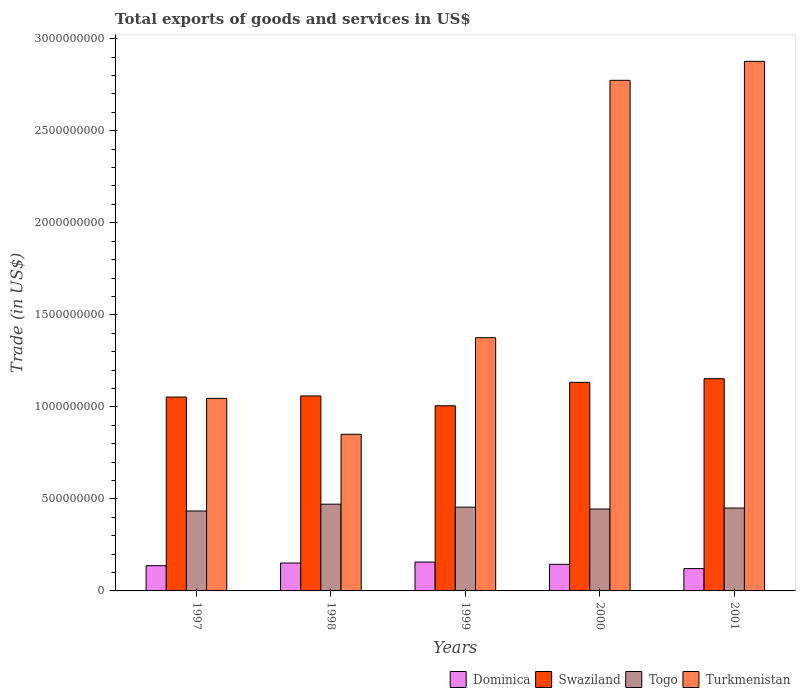How many different coloured bars are there?
Provide a succinct answer. 4. How many groups of bars are there?
Your response must be concise. 5. Are the number of bars per tick equal to the number of legend labels?
Provide a short and direct response. Yes. How many bars are there on the 3rd tick from the left?
Your response must be concise. 4. In how many cases, is the number of bars for a given year not equal to the number of legend labels?
Offer a terse response. 0. What is the total exports of goods and services in Dominica in 1998?
Make the answer very short. 1.52e+08. Across all years, what is the maximum total exports of goods and services in Turkmenistan?
Your response must be concise. 2.88e+09. Across all years, what is the minimum total exports of goods and services in Turkmenistan?
Your answer should be very brief. 8.51e+08. In which year was the total exports of goods and services in Turkmenistan minimum?
Ensure brevity in your answer.  1998. What is the total total exports of goods and services in Swaziland in the graph?
Your answer should be very brief. 5.40e+09. What is the difference between the total exports of goods and services in Togo in 1997 and that in 1999?
Make the answer very short. -2.08e+07. What is the difference between the total exports of goods and services in Togo in 1997 and the total exports of goods and services in Swaziland in 2001?
Your response must be concise. -7.19e+08. What is the average total exports of goods and services in Togo per year?
Make the answer very short. 4.51e+08. In the year 2000, what is the difference between the total exports of goods and services in Swaziland and total exports of goods and services in Togo?
Give a very brief answer. 6.88e+08. What is the ratio of the total exports of goods and services in Dominica in 1997 to that in 1998?
Ensure brevity in your answer.  0.9. Is the total exports of goods and services in Togo in 1997 less than that in 1998?
Make the answer very short. Yes. What is the difference between the highest and the second highest total exports of goods and services in Turkmenistan?
Your answer should be very brief. 1.03e+08. What is the difference between the highest and the lowest total exports of goods and services in Togo?
Make the answer very short. 3.69e+07. Is the sum of the total exports of goods and services in Swaziland in 1997 and 1999 greater than the maximum total exports of goods and services in Dominica across all years?
Offer a terse response. Yes. Is it the case that in every year, the sum of the total exports of goods and services in Togo and total exports of goods and services in Swaziland is greater than the sum of total exports of goods and services in Dominica and total exports of goods and services in Turkmenistan?
Keep it short and to the point. Yes. What does the 3rd bar from the left in 1999 represents?
Provide a short and direct response. Togo. What does the 4th bar from the right in 1997 represents?
Your answer should be very brief. Dominica. What is the difference between two consecutive major ticks on the Y-axis?
Keep it short and to the point. 5.00e+08. Are the values on the major ticks of Y-axis written in scientific E-notation?
Offer a terse response. No. Does the graph contain any zero values?
Make the answer very short. No. How many legend labels are there?
Ensure brevity in your answer.  4. What is the title of the graph?
Your response must be concise. Total exports of goods and services in US$. What is the label or title of the X-axis?
Your response must be concise. Years. What is the label or title of the Y-axis?
Your answer should be compact. Trade (in US$). What is the Trade (in US$) of Dominica in 1997?
Make the answer very short. 1.37e+08. What is the Trade (in US$) in Swaziland in 1997?
Ensure brevity in your answer.  1.05e+09. What is the Trade (in US$) in Togo in 1997?
Ensure brevity in your answer.  4.34e+08. What is the Trade (in US$) of Turkmenistan in 1997?
Your answer should be compact. 1.05e+09. What is the Trade (in US$) in Dominica in 1998?
Offer a very short reply. 1.52e+08. What is the Trade (in US$) in Swaziland in 1998?
Give a very brief answer. 1.06e+09. What is the Trade (in US$) of Togo in 1998?
Provide a succinct answer. 4.71e+08. What is the Trade (in US$) of Turkmenistan in 1998?
Your response must be concise. 8.51e+08. What is the Trade (in US$) in Dominica in 1999?
Provide a short and direct response. 1.57e+08. What is the Trade (in US$) of Swaziland in 1999?
Make the answer very short. 1.01e+09. What is the Trade (in US$) in Togo in 1999?
Provide a succinct answer. 4.55e+08. What is the Trade (in US$) in Turkmenistan in 1999?
Your answer should be very brief. 1.38e+09. What is the Trade (in US$) of Dominica in 2000?
Your answer should be compact. 1.45e+08. What is the Trade (in US$) of Swaziland in 2000?
Make the answer very short. 1.13e+09. What is the Trade (in US$) of Togo in 2000?
Provide a succinct answer. 4.45e+08. What is the Trade (in US$) of Turkmenistan in 2000?
Give a very brief answer. 2.77e+09. What is the Trade (in US$) of Dominica in 2001?
Your answer should be compact. 1.21e+08. What is the Trade (in US$) in Swaziland in 2001?
Provide a short and direct response. 1.15e+09. What is the Trade (in US$) of Togo in 2001?
Your answer should be very brief. 4.50e+08. What is the Trade (in US$) of Turkmenistan in 2001?
Provide a short and direct response. 2.88e+09. Across all years, what is the maximum Trade (in US$) in Dominica?
Give a very brief answer. 1.57e+08. Across all years, what is the maximum Trade (in US$) of Swaziland?
Ensure brevity in your answer.  1.15e+09. Across all years, what is the maximum Trade (in US$) of Togo?
Provide a short and direct response. 4.71e+08. Across all years, what is the maximum Trade (in US$) of Turkmenistan?
Make the answer very short. 2.88e+09. Across all years, what is the minimum Trade (in US$) of Dominica?
Offer a terse response. 1.21e+08. Across all years, what is the minimum Trade (in US$) in Swaziland?
Give a very brief answer. 1.01e+09. Across all years, what is the minimum Trade (in US$) in Togo?
Provide a short and direct response. 4.34e+08. Across all years, what is the minimum Trade (in US$) in Turkmenistan?
Your answer should be compact. 8.51e+08. What is the total Trade (in US$) of Dominica in the graph?
Offer a very short reply. 7.11e+08. What is the total Trade (in US$) of Swaziland in the graph?
Offer a terse response. 5.40e+09. What is the total Trade (in US$) in Togo in the graph?
Your answer should be compact. 2.26e+09. What is the total Trade (in US$) in Turkmenistan in the graph?
Give a very brief answer. 8.92e+09. What is the difference between the Trade (in US$) of Dominica in 1997 and that in 1998?
Offer a terse response. -1.45e+07. What is the difference between the Trade (in US$) in Swaziland in 1997 and that in 1998?
Your response must be concise. -6.06e+06. What is the difference between the Trade (in US$) in Togo in 1997 and that in 1998?
Keep it short and to the point. -3.69e+07. What is the difference between the Trade (in US$) of Turkmenistan in 1997 and that in 1998?
Give a very brief answer. 1.95e+08. What is the difference between the Trade (in US$) of Dominica in 1997 and that in 1999?
Give a very brief answer. -1.97e+07. What is the difference between the Trade (in US$) of Swaziland in 1997 and that in 1999?
Offer a terse response. 4.71e+07. What is the difference between the Trade (in US$) of Togo in 1997 and that in 1999?
Your response must be concise. -2.08e+07. What is the difference between the Trade (in US$) in Turkmenistan in 1997 and that in 1999?
Your response must be concise. -3.30e+08. What is the difference between the Trade (in US$) of Dominica in 1997 and that in 2000?
Make the answer very short. -7.36e+06. What is the difference between the Trade (in US$) of Swaziland in 1997 and that in 2000?
Keep it short and to the point. -7.99e+07. What is the difference between the Trade (in US$) of Togo in 1997 and that in 2000?
Ensure brevity in your answer.  -1.07e+07. What is the difference between the Trade (in US$) in Turkmenistan in 1997 and that in 2000?
Your response must be concise. -1.73e+09. What is the difference between the Trade (in US$) of Dominica in 1997 and that in 2001?
Your answer should be compact. 1.59e+07. What is the difference between the Trade (in US$) of Swaziland in 1997 and that in 2001?
Your answer should be compact. -9.97e+07. What is the difference between the Trade (in US$) in Togo in 1997 and that in 2001?
Your answer should be compact. -1.60e+07. What is the difference between the Trade (in US$) in Turkmenistan in 1997 and that in 2001?
Make the answer very short. -1.83e+09. What is the difference between the Trade (in US$) of Dominica in 1998 and that in 1999?
Give a very brief answer. -5.21e+06. What is the difference between the Trade (in US$) of Swaziland in 1998 and that in 1999?
Your answer should be very brief. 5.31e+07. What is the difference between the Trade (in US$) in Togo in 1998 and that in 1999?
Your answer should be compact. 1.61e+07. What is the difference between the Trade (in US$) of Turkmenistan in 1998 and that in 1999?
Provide a succinct answer. -5.25e+08. What is the difference between the Trade (in US$) of Dominica in 1998 and that in 2000?
Keep it short and to the point. 7.09e+06. What is the difference between the Trade (in US$) in Swaziland in 1998 and that in 2000?
Your response must be concise. -7.38e+07. What is the difference between the Trade (in US$) of Togo in 1998 and that in 2000?
Offer a very short reply. 2.62e+07. What is the difference between the Trade (in US$) of Turkmenistan in 1998 and that in 2000?
Your answer should be very brief. -1.92e+09. What is the difference between the Trade (in US$) of Dominica in 1998 and that in 2001?
Ensure brevity in your answer.  3.04e+07. What is the difference between the Trade (in US$) of Swaziland in 1998 and that in 2001?
Ensure brevity in your answer.  -9.36e+07. What is the difference between the Trade (in US$) in Togo in 1998 and that in 2001?
Give a very brief answer. 2.09e+07. What is the difference between the Trade (in US$) of Turkmenistan in 1998 and that in 2001?
Your answer should be very brief. -2.03e+09. What is the difference between the Trade (in US$) in Dominica in 1999 and that in 2000?
Offer a terse response. 1.23e+07. What is the difference between the Trade (in US$) in Swaziland in 1999 and that in 2000?
Provide a short and direct response. -1.27e+08. What is the difference between the Trade (in US$) in Togo in 1999 and that in 2000?
Offer a very short reply. 1.01e+07. What is the difference between the Trade (in US$) in Turkmenistan in 1999 and that in 2000?
Keep it short and to the point. -1.40e+09. What is the difference between the Trade (in US$) of Dominica in 1999 and that in 2001?
Your answer should be compact. 3.56e+07. What is the difference between the Trade (in US$) of Swaziland in 1999 and that in 2001?
Offer a terse response. -1.47e+08. What is the difference between the Trade (in US$) of Togo in 1999 and that in 2001?
Ensure brevity in your answer.  4.75e+06. What is the difference between the Trade (in US$) of Turkmenistan in 1999 and that in 2001?
Make the answer very short. -1.50e+09. What is the difference between the Trade (in US$) of Dominica in 2000 and that in 2001?
Your answer should be compact. 2.33e+07. What is the difference between the Trade (in US$) of Swaziland in 2000 and that in 2001?
Your answer should be compact. -1.98e+07. What is the difference between the Trade (in US$) in Togo in 2000 and that in 2001?
Keep it short and to the point. -5.34e+06. What is the difference between the Trade (in US$) in Turkmenistan in 2000 and that in 2001?
Your answer should be compact. -1.03e+08. What is the difference between the Trade (in US$) in Dominica in 1997 and the Trade (in US$) in Swaziland in 1998?
Ensure brevity in your answer.  -9.22e+08. What is the difference between the Trade (in US$) of Dominica in 1997 and the Trade (in US$) of Togo in 1998?
Make the answer very short. -3.34e+08. What is the difference between the Trade (in US$) of Dominica in 1997 and the Trade (in US$) of Turkmenistan in 1998?
Make the answer very short. -7.14e+08. What is the difference between the Trade (in US$) of Swaziland in 1997 and the Trade (in US$) of Togo in 1998?
Provide a succinct answer. 5.82e+08. What is the difference between the Trade (in US$) in Swaziland in 1997 and the Trade (in US$) in Turkmenistan in 1998?
Make the answer very short. 2.02e+08. What is the difference between the Trade (in US$) in Togo in 1997 and the Trade (in US$) in Turkmenistan in 1998?
Keep it short and to the point. -4.17e+08. What is the difference between the Trade (in US$) in Dominica in 1997 and the Trade (in US$) in Swaziland in 1999?
Your response must be concise. -8.69e+08. What is the difference between the Trade (in US$) in Dominica in 1997 and the Trade (in US$) in Togo in 1999?
Offer a terse response. -3.18e+08. What is the difference between the Trade (in US$) of Dominica in 1997 and the Trade (in US$) of Turkmenistan in 1999?
Provide a short and direct response. -1.24e+09. What is the difference between the Trade (in US$) of Swaziland in 1997 and the Trade (in US$) of Togo in 1999?
Ensure brevity in your answer.  5.98e+08. What is the difference between the Trade (in US$) in Swaziland in 1997 and the Trade (in US$) in Turkmenistan in 1999?
Offer a very short reply. -3.23e+08. What is the difference between the Trade (in US$) in Togo in 1997 and the Trade (in US$) in Turkmenistan in 1999?
Your response must be concise. -9.41e+08. What is the difference between the Trade (in US$) in Dominica in 1997 and the Trade (in US$) in Swaziland in 2000?
Ensure brevity in your answer.  -9.96e+08. What is the difference between the Trade (in US$) in Dominica in 1997 and the Trade (in US$) in Togo in 2000?
Give a very brief answer. -3.08e+08. What is the difference between the Trade (in US$) of Dominica in 1997 and the Trade (in US$) of Turkmenistan in 2000?
Provide a succinct answer. -2.64e+09. What is the difference between the Trade (in US$) in Swaziland in 1997 and the Trade (in US$) in Togo in 2000?
Ensure brevity in your answer.  6.08e+08. What is the difference between the Trade (in US$) of Swaziland in 1997 and the Trade (in US$) of Turkmenistan in 2000?
Provide a short and direct response. -1.72e+09. What is the difference between the Trade (in US$) of Togo in 1997 and the Trade (in US$) of Turkmenistan in 2000?
Give a very brief answer. -2.34e+09. What is the difference between the Trade (in US$) in Dominica in 1997 and the Trade (in US$) in Swaziland in 2001?
Keep it short and to the point. -1.02e+09. What is the difference between the Trade (in US$) of Dominica in 1997 and the Trade (in US$) of Togo in 2001?
Your answer should be very brief. -3.13e+08. What is the difference between the Trade (in US$) in Dominica in 1997 and the Trade (in US$) in Turkmenistan in 2001?
Offer a terse response. -2.74e+09. What is the difference between the Trade (in US$) in Swaziland in 1997 and the Trade (in US$) in Togo in 2001?
Give a very brief answer. 6.03e+08. What is the difference between the Trade (in US$) of Swaziland in 1997 and the Trade (in US$) of Turkmenistan in 2001?
Offer a very short reply. -1.82e+09. What is the difference between the Trade (in US$) in Togo in 1997 and the Trade (in US$) in Turkmenistan in 2001?
Offer a terse response. -2.44e+09. What is the difference between the Trade (in US$) in Dominica in 1998 and the Trade (in US$) in Swaziland in 1999?
Provide a succinct answer. -8.55e+08. What is the difference between the Trade (in US$) in Dominica in 1998 and the Trade (in US$) in Togo in 1999?
Make the answer very short. -3.03e+08. What is the difference between the Trade (in US$) in Dominica in 1998 and the Trade (in US$) in Turkmenistan in 1999?
Provide a short and direct response. -1.22e+09. What is the difference between the Trade (in US$) of Swaziland in 1998 and the Trade (in US$) of Togo in 1999?
Your response must be concise. 6.04e+08. What is the difference between the Trade (in US$) of Swaziland in 1998 and the Trade (in US$) of Turkmenistan in 1999?
Provide a succinct answer. -3.17e+08. What is the difference between the Trade (in US$) in Togo in 1998 and the Trade (in US$) in Turkmenistan in 1999?
Make the answer very short. -9.05e+08. What is the difference between the Trade (in US$) of Dominica in 1998 and the Trade (in US$) of Swaziland in 2000?
Your answer should be compact. -9.82e+08. What is the difference between the Trade (in US$) in Dominica in 1998 and the Trade (in US$) in Togo in 2000?
Ensure brevity in your answer.  -2.93e+08. What is the difference between the Trade (in US$) of Dominica in 1998 and the Trade (in US$) of Turkmenistan in 2000?
Give a very brief answer. -2.62e+09. What is the difference between the Trade (in US$) of Swaziland in 1998 and the Trade (in US$) of Togo in 2000?
Offer a very short reply. 6.14e+08. What is the difference between the Trade (in US$) of Swaziland in 1998 and the Trade (in US$) of Turkmenistan in 2000?
Your answer should be very brief. -1.71e+09. What is the difference between the Trade (in US$) of Togo in 1998 and the Trade (in US$) of Turkmenistan in 2000?
Give a very brief answer. -2.30e+09. What is the difference between the Trade (in US$) of Dominica in 1998 and the Trade (in US$) of Swaziland in 2001?
Give a very brief answer. -1.00e+09. What is the difference between the Trade (in US$) in Dominica in 1998 and the Trade (in US$) in Togo in 2001?
Offer a very short reply. -2.99e+08. What is the difference between the Trade (in US$) of Dominica in 1998 and the Trade (in US$) of Turkmenistan in 2001?
Offer a terse response. -2.73e+09. What is the difference between the Trade (in US$) of Swaziland in 1998 and the Trade (in US$) of Togo in 2001?
Your response must be concise. 6.09e+08. What is the difference between the Trade (in US$) of Swaziland in 1998 and the Trade (in US$) of Turkmenistan in 2001?
Make the answer very short. -1.82e+09. What is the difference between the Trade (in US$) of Togo in 1998 and the Trade (in US$) of Turkmenistan in 2001?
Make the answer very short. -2.41e+09. What is the difference between the Trade (in US$) of Dominica in 1999 and the Trade (in US$) of Swaziland in 2000?
Offer a terse response. -9.76e+08. What is the difference between the Trade (in US$) in Dominica in 1999 and the Trade (in US$) in Togo in 2000?
Offer a very short reply. -2.88e+08. What is the difference between the Trade (in US$) in Dominica in 1999 and the Trade (in US$) in Turkmenistan in 2000?
Offer a terse response. -2.62e+09. What is the difference between the Trade (in US$) of Swaziland in 1999 and the Trade (in US$) of Togo in 2000?
Your response must be concise. 5.61e+08. What is the difference between the Trade (in US$) in Swaziland in 1999 and the Trade (in US$) in Turkmenistan in 2000?
Your answer should be very brief. -1.77e+09. What is the difference between the Trade (in US$) of Togo in 1999 and the Trade (in US$) of Turkmenistan in 2000?
Your answer should be very brief. -2.32e+09. What is the difference between the Trade (in US$) of Dominica in 1999 and the Trade (in US$) of Swaziland in 2001?
Your response must be concise. -9.96e+08. What is the difference between the Trade (in US$) in Dominica in 1999 and the Trade (in US$) in Togo in 2001?
Provide a short and direct response. -2.94e+08. What is the difference between the Trade (in US$) of Dominica in 1999 and the Trade (in US$) of Turkmenistan in 2001?
Provide a short and direct response. -2.72e+09. What is the difference between the Trade (in US$) in Swaziland in 1999 and the Trade (in US$) in Togo in 2001?
Offer a very short reply. 5.56e+08. What is the difference between the Trade (in US$) of Swaziland in 1999 and the Trade (in US$) of Turkmenistan in 2001?
Your answer should be very brief. -1.87e+09. What is the difference between the Trade (in US$) of Togo in 1999 and the Trade (in US$) of Turkmenistan in 2001?
Keep it short and to the point. -2.42e+09. What is the difference between the Trade (in US$) in Dominica in 2000 and the Trade (in US$) in Swaziland in 2001?
Offer a very short reply. -1.01e+09. What is the difference between the Trade (in US$) of Dominica in 2000 and the Trade (in US$) of Togo in 2001?
Your response must be concise. -3.06e+08. What is the difference between the Trade (in US$) of Dominica in 2000 and the Trade (in US$) of Turkmenistan in 2001?
Ensure brevity in your answer.  -2.73e+09. What is the difference between the Trade (in US$) in Swaziland in 2000 and the Trade (in US$) in Togo in 2001?
Provide a short and direct response. 6.83e+08. What is the difference between the Trade (in US$) in Swaziland in 2000 and the Trade (in US$) in Turkmenistan in 2001?
Keep it short and to the point. -1.74e+09. What is the difference between the Trade (in US$) of Togo in 2000 and the Trade (in US$) of Turkmenistan in 2001?
Keep it short and to the point. -2.43e+09. What is the average Trade (in US$) of Dominica per year?
Offer a very short reply. 1.42e+08. What is the average Trade (in US$) in Swaziland per year?
Provide a short and direct response. 1.08e+09. What is the average Trade (in US$) in Togo per year?
Your response must be concise. 4.51e+08. What is the average Trade (in US$) of Turkmenistan per year?
Provide a succinct answer. 1.78e+09. In the year 1997, what is the difference between the Trade (in US$) of Dominica and Trade (in US$) of Swaziland?
Ensure brevity in your answer.  -9.16e+08. In the year 1997, what is the difference between the Trade (in US$) of Dominica and Trade (in US$) of Togo?
Offer a very short reply. -2.97e+08. In the year 1997, what is the difference between the Trade (in US$) of Dominica and Trade (in US$) of Turkmenistan?
Your response must be concise. -9.09e+08. In the year 1997, what is the difference between the Trade (in US$) of Swaziland and Trade (in US$) of Togo?
Your response must be concise. 6.19e+08. In the year 1997, what is the difference between the Trade (in US$) of Swaziland and Trade (in US$) of Turkmenistan?
Your answer should be compact. 7.31e+06. In the year 1997, what is the difference between the Trade (in US$) of Togo and Trade (in US$) of Turkmenistan?
Provide a short and direct response. -6.12e+08. In the year 1998, what is the difference between the Trade (in US$) in Dominica and Trade (in US$) in Swaziland?
Ensure brevity in your answer.  -9.08e+08. In the year 1998, what is the difference between the Trade (in US$) of Dominica and Trade (in US$) of Togo?
Provide a short and direct response. -3.20e+08. In the year 1998, what is the difference between the Trade (in US$) of Dominica and Trade (in US$) of Turkmenistan?
Your response must be concise. -6.99e+08. In the year 1998, what is the difference between the Trade (in US$) of Swaziland and Trade (in US$) of Togo?
Your answer should be compact. 5.88e+08. In the year 1998, what is the difference between the Trade (in US$) of Swaziland and Trade (in US$) of Turkmenistan?
Ensure brevity in your answer.  2.08e+08. In the year 1998, what is the difference between the Trade (in US$) of Togo and Trade (in US$) of Turkmenistan?
Give a very brief answer. -3.80e+08. In the year 1999, what is the difference between the Trade (in US$) of Dominica and Trade (in US$) of Swaziland?
Make the answer very short. -8.49e+08. In the year 1999, what is the difference between the Trade (in US$) in Dominica and Trade (in US$) in Togo?
Keep it short and to the point. -2.98e+08. In the year 1999, what is the difference between the Trade (in US$) in Dominica and Trade (in US$) in Turkmenistan?
Make the answer very short. -1.22e+09. In the year 1999, what is the difference between the Trade (in US$) in Swaziland and Trade (in US$) in Togo?
Make the answer very short. 5.51e+08. In the year 1999, what is the difference between the Trade (in US$) of Swaziland and Trade (in US$) of Turkmenistan?
Make the answer very short. -3.70e+08. In the year 1999, what is the difference between the Trade (in US$) in Togo and Trade (in US$) in Turkmenistan?
Provide a short and direct response. -9.21e+08. In the year 2000, what is the difference between the Trade (in US$) in Dominica and Trade (in US$) in Swaziland?
Your answer should be compact. -9.89e+08. In the year 2000, what is the difference between the Trade (in US$) in Dominica and Trade (in US$) in Togo?
Offer a very short reply. -3.00e+08. In the year 2000, what is the difference between the Trade (in US$) of Dominica and Trade (in US$) of Turkmenistan?
Your answer should be compact. -2.63e+09. In the year 2000, what is the difference between the Trade (in US$) in Swaziland and Trade (in US$) in Togo?
Your answer should be compact. 6.88e+08. In the year 2000, what is the difference between the Trade (in US$) of Swaziland and Trade (in US$) of Turkmenistan?
Provide a short and direct response. -1.64e+09. In the year 2000, what is the difference between the Trade (in US$) of Togo and Trade (in US$) of Turkmenistan?
Provide a succinct answer. -2.33e+09. In the year 2001, what is the difference between the Trade (in US$) in Dominica and Trade (in US$) in Swaziland?
Your answer should be very brief. -1.03e+09. In the year 2001, what is the difference between the Trade (in US$) of Dominica and Trade (in US$) of Togo?
Ensure brevity in your answer.  -3.29e+08. In the year 2001, what is the difference between the Trade (in US$) in Dominica and Trade (in US$) in Turkmenistan?
Your response must be concise. -2.76e+09. In the year 2001, what is the difference between the Trade (in US$) in Swaziland and Trade (in US$) in Togo?
Your answer should be very brief. 7.03e+08. In the year 2001, what is the difference between the Trade (in US$) of Swaziland and Trade (in US$) of Turkmenistan?
Offer a very short reply. -1.72e+09. In the year 2001, what is the difference between the Trade (in US$) in Togo and Trade (in US$) in Turkmenistan?
Your answer should be compact. -2.43e+09. What is the ratio of the Trade (in US$) of Dominica in 1997 to that in 1998?
Offer a very short reply. 0.9. What is the ratio of the Trade (in US$) in Togo in 1997 to that in 1998?
Give a very brief answer. 0.92. What is the ratio of the Trade (in US$) of Turkmenistan in 1997 to that in 1998?
Offer a very short reply. 1.23. What is the ratio of the Trade (in US$) in Dominica in 1997 to that in 1999?
Give a very brief answer. 0.87. What is the ratio of the Trade (in US$) in Swaziland in 1997 to that in 1999?
Make the answer very short. 1.05. What is the ratio of the Trade (in US$) of Togo in 1997 to that in 1999?
Your response must be concise. 0.95. What is the ratio of the Trade (in US$) in Turkmenistan in 1997 to that in 1999?
Your answer should be very brief. 0.76. What is the ratio of the Trade (in US$) in Dominica in 1997 to that in 2000?
Keep it short and to the point. 0.95. What is the ratio of the Trade (in US$) in Swaziland in 1997 to that in 2000?
Give a very brief answer. 0.93. What is the ratio of the Trade (in US$) in Togo in 1997 to that in 2000?
Offer a terse response. 0.98. What is the ratio of the Trade (in US$) of Turkmenistan in 1997 to that in 2000?
Your answer should be very brief. 0.38. What is the ratio of the Trade (in US$) in Dominica in 1997 to that in 2001?
Your answer should be compact. 1.13. What is the ratio of the Trade (in US$) in Swaziland in 1997 to that in 2001?
Your response must be concise. 0.91. What is the ratio of the Trade (in US$) of Togo in 1997 to that in 2001?
Your answer should be very brief. 0.96. What is the ratio of the Trade (in US$) of Turkmenistan in 1997 to that in 2001?
Your answer should be very brief. 0.36. What is the ratio of the Trade (in US$) of Dominica in 1998 to that in 1999?
Your answer should be compact. 0.97. What is the ratio of the Trade (in US$) in Swaziland in 1998 to that in 1999?
Provide a short and direct response. 1.05. What is the ratio of the Trade (in US$) in Togo in 1998 to that in 1999?
Make the answer very short. 1.04. What is the ratio of the Trade (in US$) in Turkmenistan in 1998 to that in 1999?
Provide a succinct answer. 0.62. What is the ratio of the Trade (in US$) in Dominica in 1998 to that in 2000?
Offer a terse response. 1.05. What is the ratio of the Trade (in US$) in Swaziland in 1998 to that in 2000?
Offer a terse response. 0.93. What is the ratio of the Trade (in US$) of Togo in 1998 to that in 2000?
Ensure brevity in your answer.  1.06. What is the ratio of the Trade (in US$) in Turkmenistan in 1998 to that in 2000?
Provide a succinct answer. 0.31. What is the ratio of the Trade (in US$) of Dominica in 1998 to that in 2001?
Give a very brief answer. 1.25. What is the ratio of the Trade (in US$) of Swaziland in 1998 to that in 2001?
Offer a very short reply. 0.92. What is the ratio of the Trade (in US$) of Togo in 1998 to that in 2001?
Provide a succinct answer. 1.05. What is the ratio of the Trade (in US$) in Turkmenistan in 1998 to that in 2001?
Make the answer very short. 0.3. What is the ratio of the Trade (in US$) in Dominica in 1999 to that in 2000?
Your answer should be compact. 1.09. What is the ratio of the Trade (in US$) of Swaziland in 1999 to that in 2000?
Offer a terse response. 0.89. What is the ratio of the Trade (in US$) of Togo in 1999 to that in 2000?
Offer a terse response. 1.02. What is the ratio of the Trade (in US$) of Turkmenistan in 1999 to that in 2000?
Ensure brevity in your answer.  0.5. What is the ratio of the Trade (in US$) in Dominica in 1999 to that in 2001?
Offer a very short reply. 1.29. What is the ratio of the Trade (in US$) in Swaziland in 1999 to that in 2001?
Keep it short and to the point. 0.87. What is the ratio of the Trade (in US$) of Togo in 1999 to that in 2001?
Offer a very short reply. 1.01. What is the ratio of the Trade (in US$) in Turkmenistan in 1999 to that in 2001?
Keep it short and to the point. 0.48. What is the ratio of the Trade (in US$) of Dominica in 2000 to that in 2001?
Provide a succinct answer. 1.19. What is the ratio of the Trade (in US$) in Swaziland in 2000 to that in 2001?
Offer a terse response. 0.98. What is the ratio of the Trade (in US$) in Togo in 2000 to that in 2001?
Make the answer very short. 0.99. What is the ratio of the Trade (in US$) in Turkmenistan in 2000 to that in 2001?
Your answer should be compact. 0.96. What is the difference between the highest and the second highest Trade (in US$) of Dominica?
Make the answer very short. 5.21e+06. What is the difference between the highest and the second highest Trade (in US$) in Swaziland?
Give a very brief answer. 1.98e+07. What is the difference between the highest and the second highest Trade (in US$) of Togo?
Offer a terse response. 1.61e+07. What is the difference between the highest and the second highest Trade (in US$) in Turkmenistan?
Ensure brevity in your answer.  1.03e+08. What is the difference between the highest and the lowest Trade (in US$) in Dominica?
Provide a succinct answer. 3.56e+07. What is the difference between the highest and the lowest Trade (in US$) in Swaziland?
Provide a short and direct response. 1.47e+08. What is the difference between the highest and the lowest Trade (in US$) of Togo?
Give a very brief answer. 3.69e+07. What is the difference between the highest and the lowest Trade (in US$) in Turkmenistan?
Offer a very short reply. 2.03e+09. 